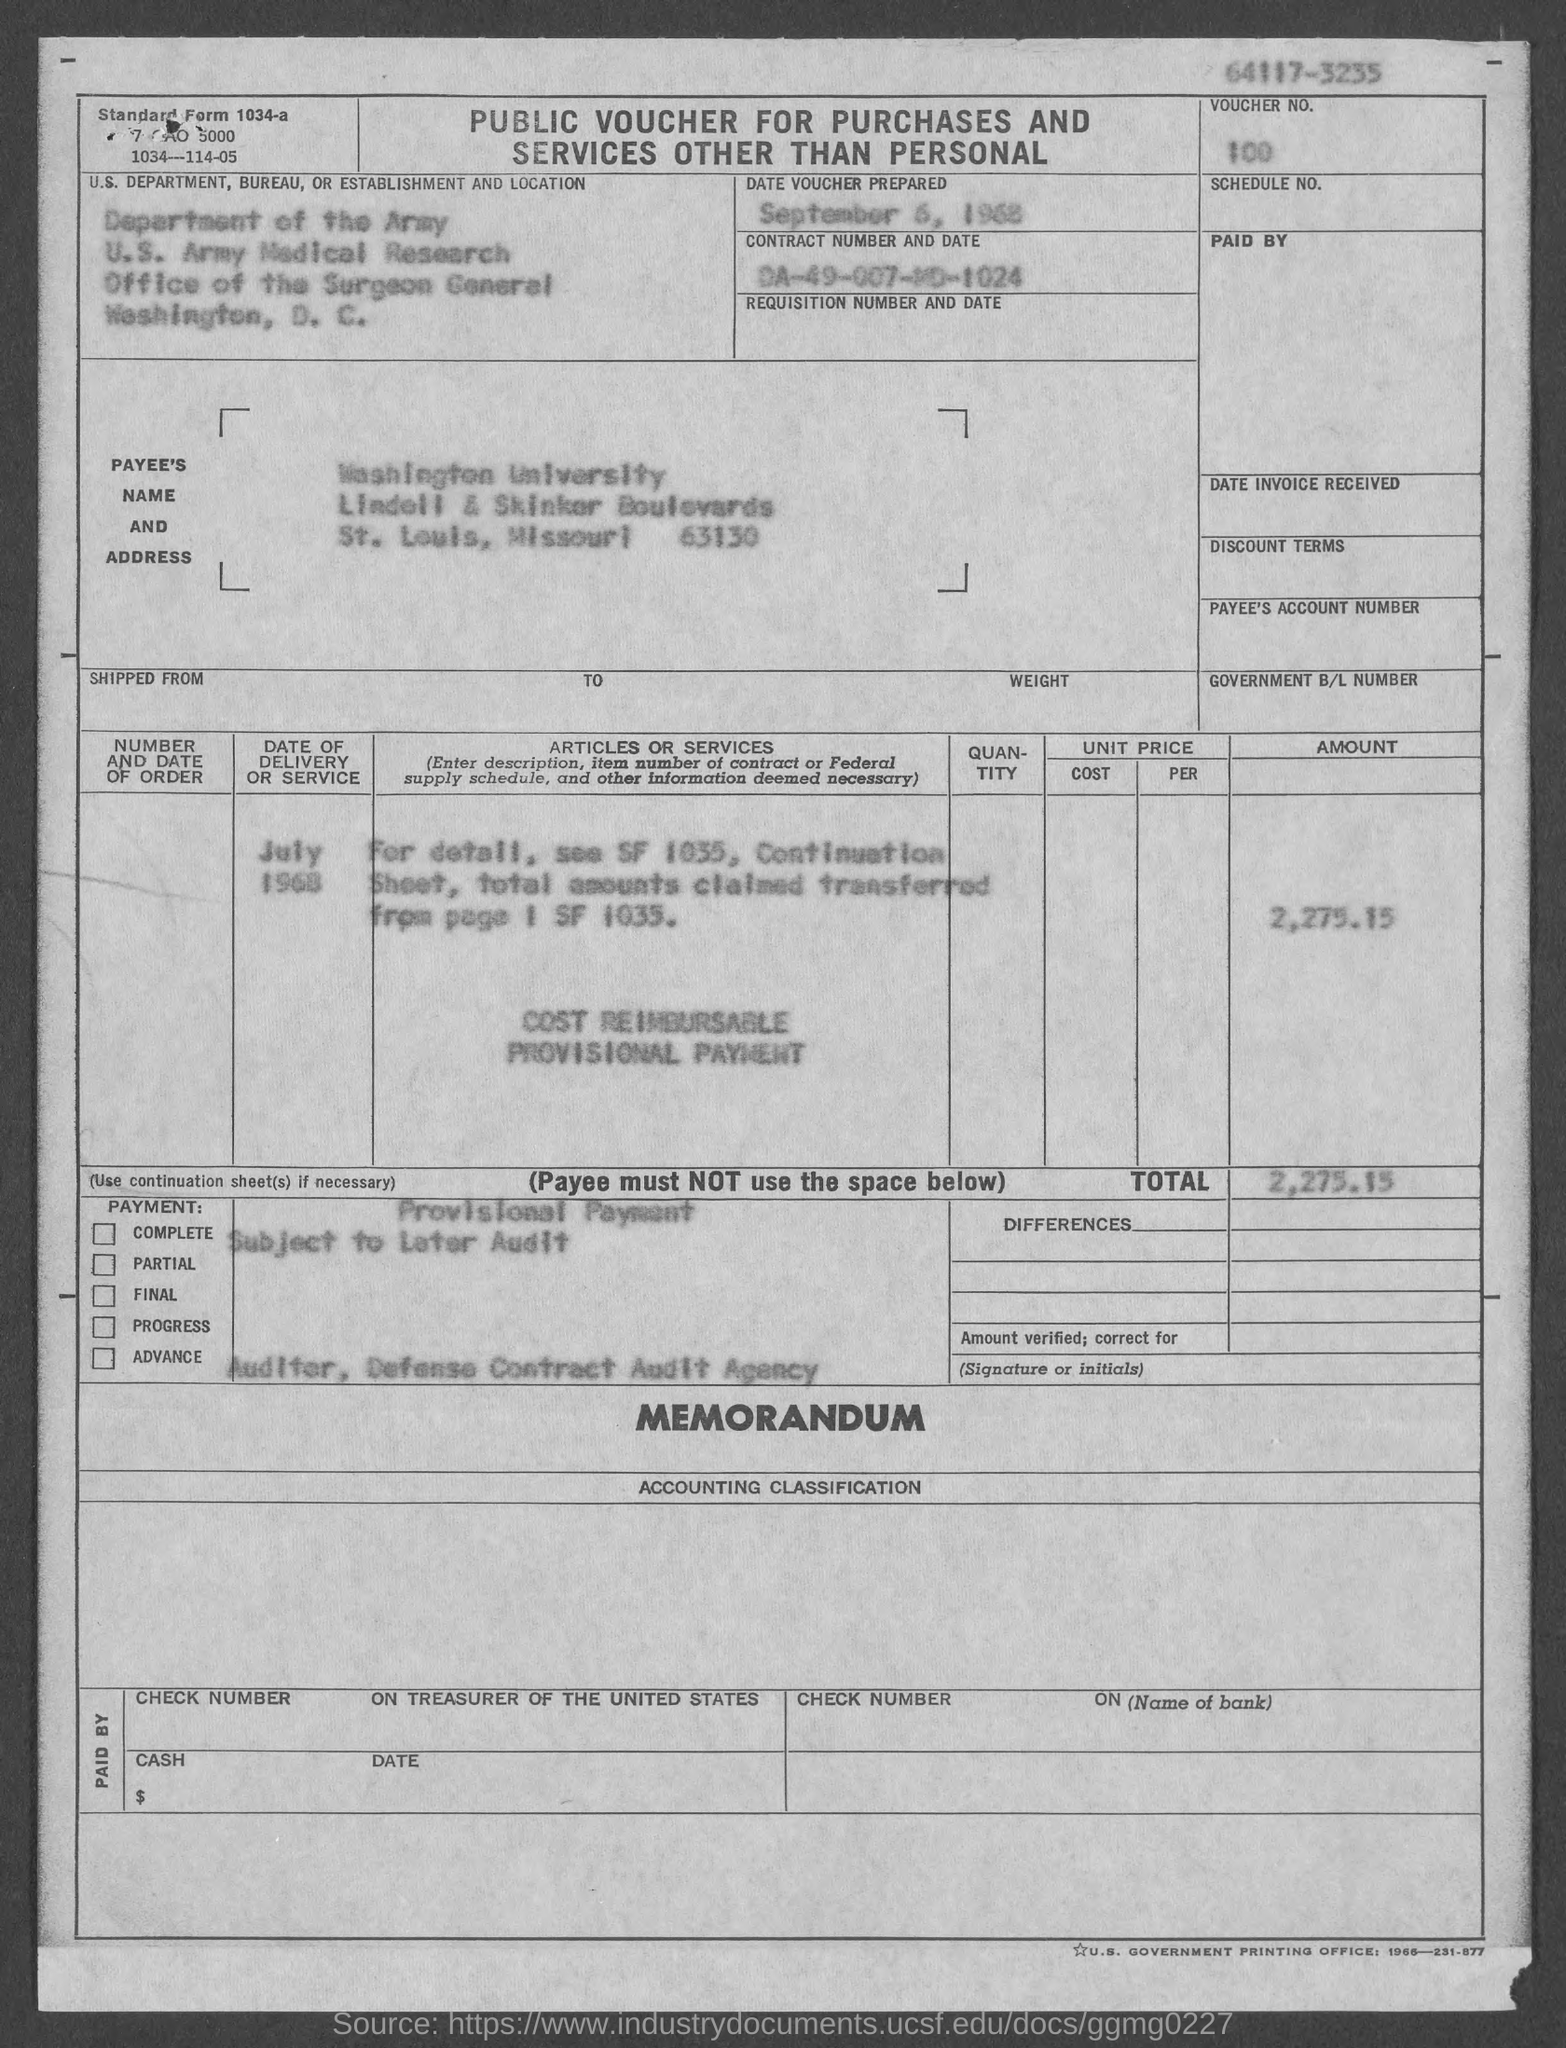What is the voucher no.?
Offer a very short reply. 100. When is the date voucher prepared ?
Ensure brevity in your answer.  September 6, 1968. What is the payee's name ?
Your answer should be compact. Washington University. What is the total voucher amount ?
Keep it short and to the point. $2,275.15. 